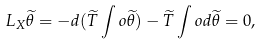<formula> <loc_0><loc_0><loc_500><loc_500>L _ { X } \widetilde { \theta } = - d ( \widetilde { T } \int o \widetilde { \theta } ) - \widetilde { T } \int o d \widetilde { \theta } = 0 ,</formula> 